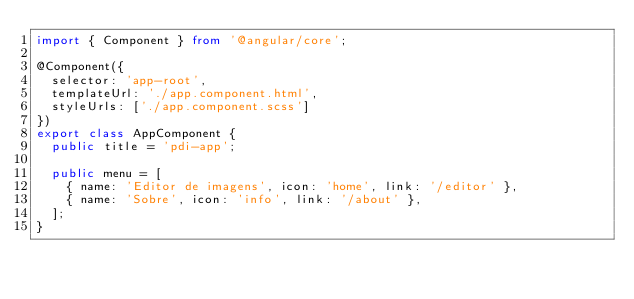Convert code to text. <code><loc_0><loc_0><loc_500><loc_500><_TypeScript_>import { Component } from '@angular/core';

@Component({
  selector: 'app-root',
  templateUrl: './app.component.html',
  styleUrls: ['./app.component.scss']
})
export class AppComponent {
  public title = 'pdi-app';

  public menu = [
    { name: 'Editor de imagens', icon: 'home', link: '/editor' },
    { name: 'Sobre', icon: 'info', link: '/about' },
  ];
}
</code> 